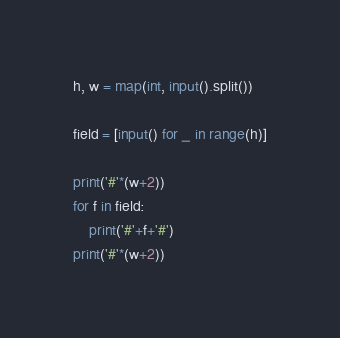Convert code to text. <code><loc_0><loc_0><loc_500><loc_500><_Python_>h, w = map(int, input().split())

field = [input() for _ in range(h)]

print('#'*(w+2))
for f in field:
    print('#'+f+'#')
print('#'*(w+2))</code> 